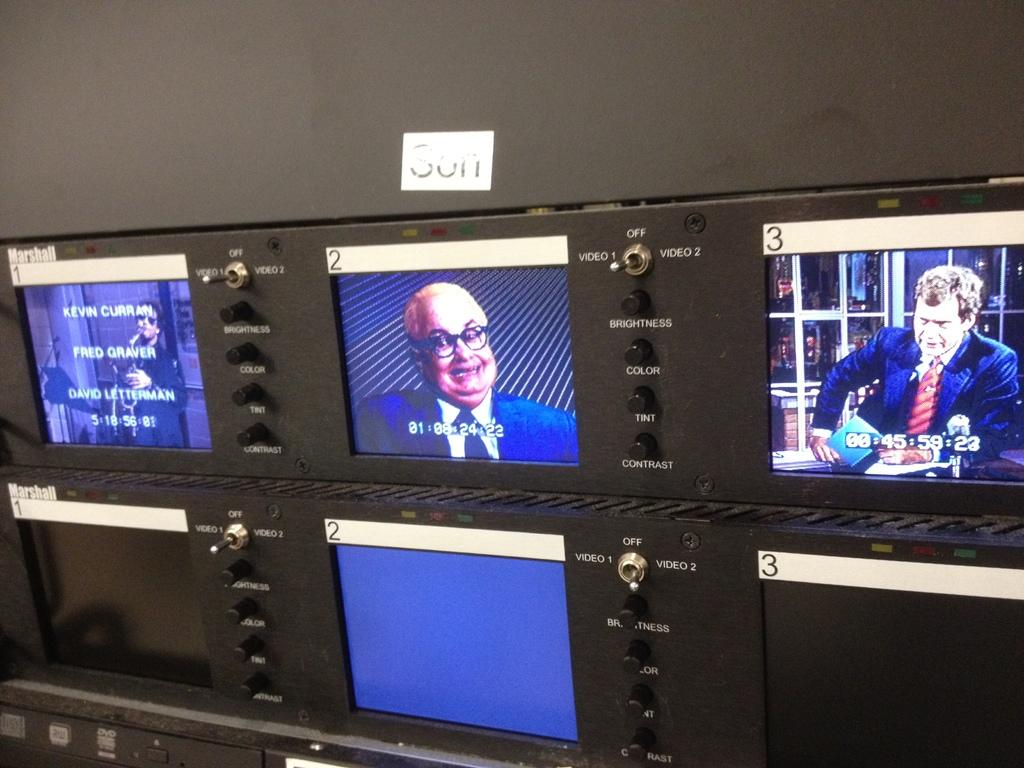Provide a one-sentence caption for the provided image. A row of monitors is showing different TV channels and a tag above them says Son. 